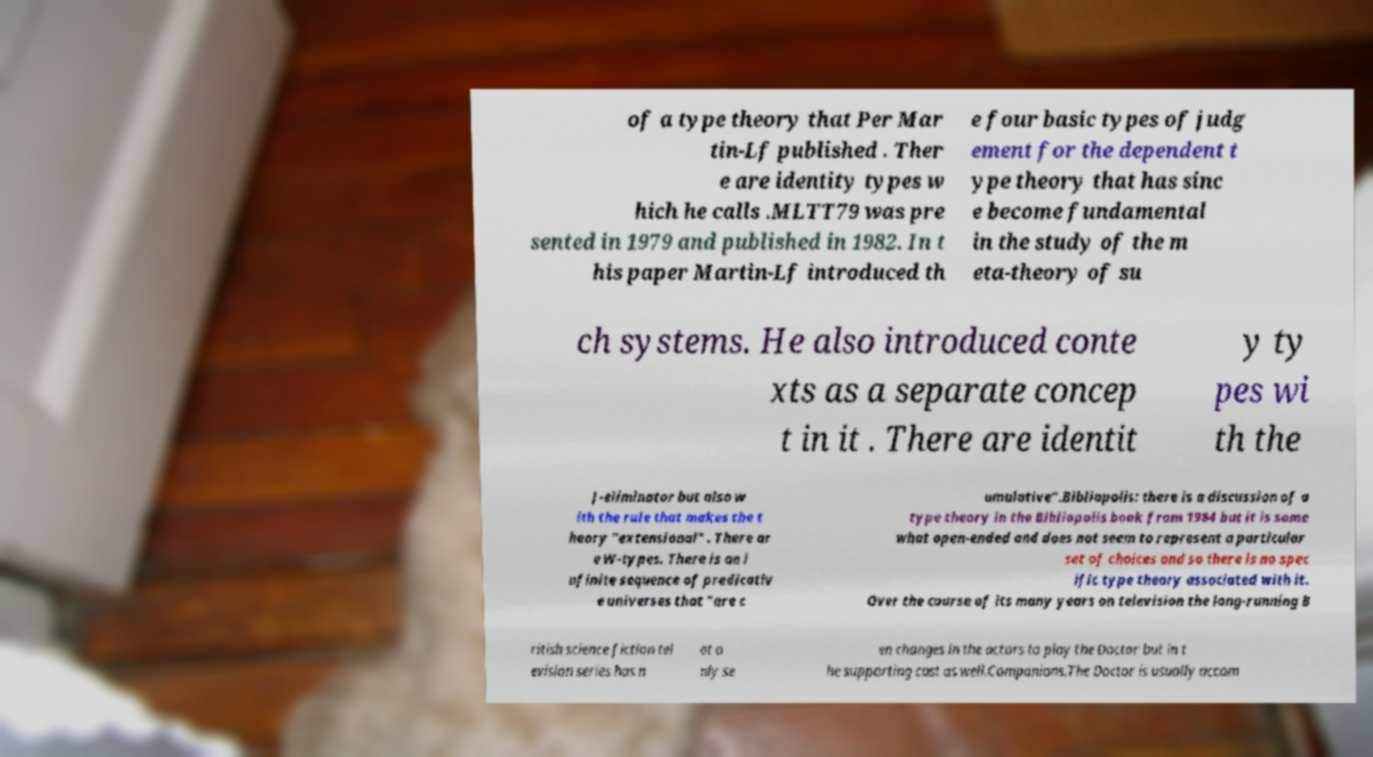What messages or text are displayed in this image? I need them in a readable, typed format. of a type theory that Per Mar tin-Lf published . Ther e are identity types w hich he calls .MLTT79 was pre sented in 1979 and published in 1982. In t his paper Martin-Lf introduced th e four basic types of judg ement for the dependent t ype theory that has sinc e become fundamental in the study of the m eta-theory of su ch systems. He also introduced conte xts as a separate concep t in it . There are identit y ty pes wi th the J-eliminator but also w ith the rule that makes the t heory "extensional" . There ar e W-types. There is an i nfinite sequence of predicativ e universes that "are c umulative".Bibliopolis: there is a discussion of a type theory in the Bibliopolis book from 1984 but it is some what open-ended and does not seem to represent a particular set of choices and so there is no spec ific type theory associated with it. Over the course of its many years on television the long-running B ritish science fiction tel evision series has n ot o nly se en changes in the actors to play the Doctor but in t he supporting cast as well.Companions.The Doctor is usually accom 